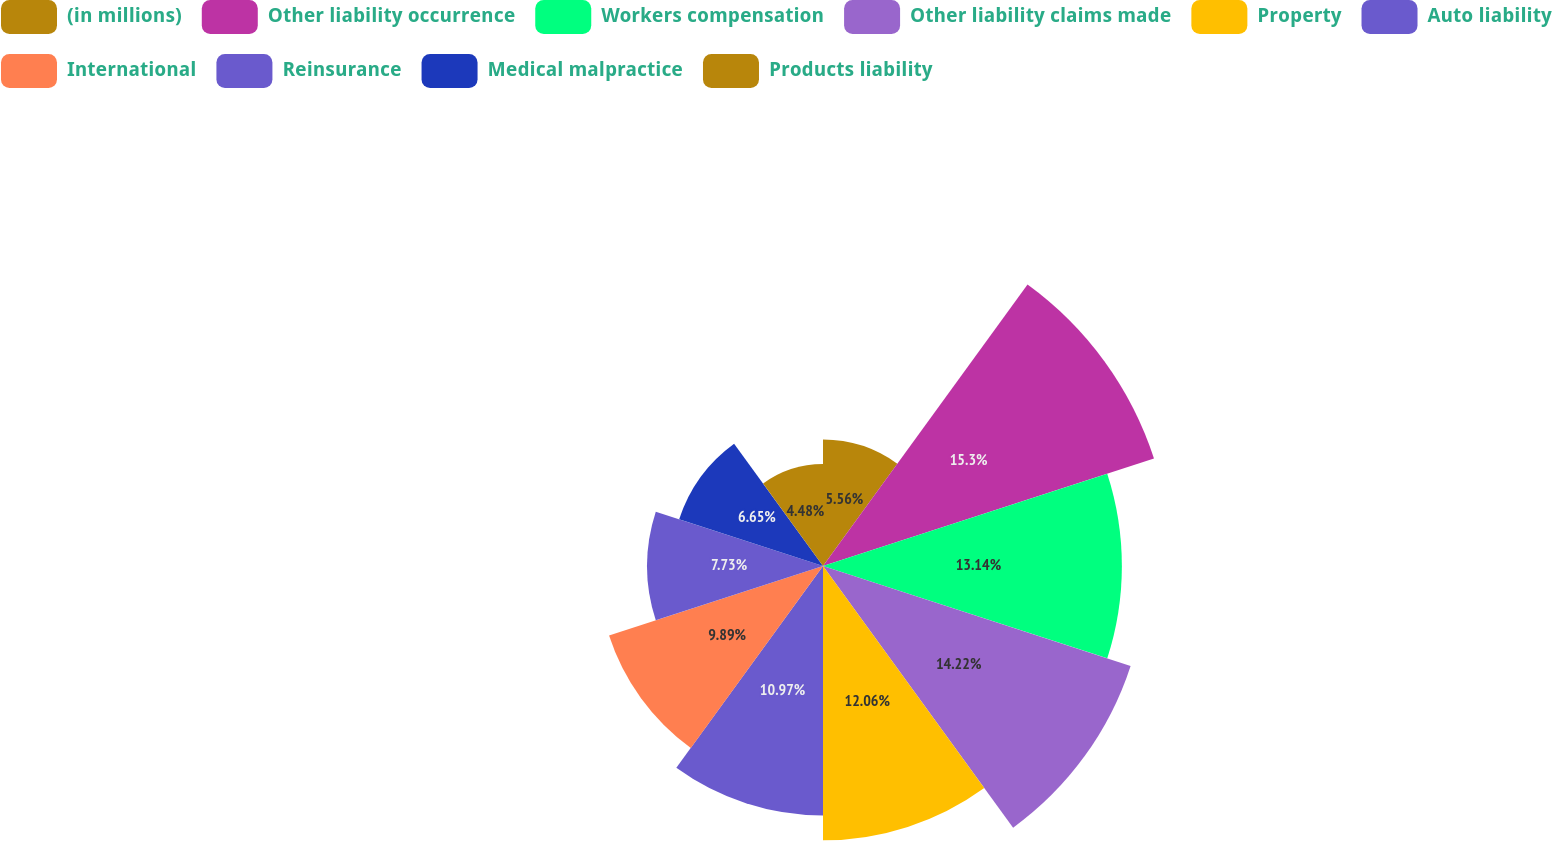Convert chart to OTSL. <chart><loc_0><loc_0><loc_500><loc_500><pie_chart><fcel>(in millions)<fcel>Other liability occurrence<fcel>Workers compensation<fcel>Other liability claims made<fcel>Property<fcel>Auto liability<fcel>International<fcel>Reinsurance<fcel>Medical malpractice<fcel>Products liability<nl><fcel>5.56%<fcel>15.3%<fcel>13.14%<fcel>14.22%<fcel>12.06%<fcel>10.97%<fcel>9.89%<fcel>7.73%<fcel>6.65%<fcel>4.48%<nl></chart> 